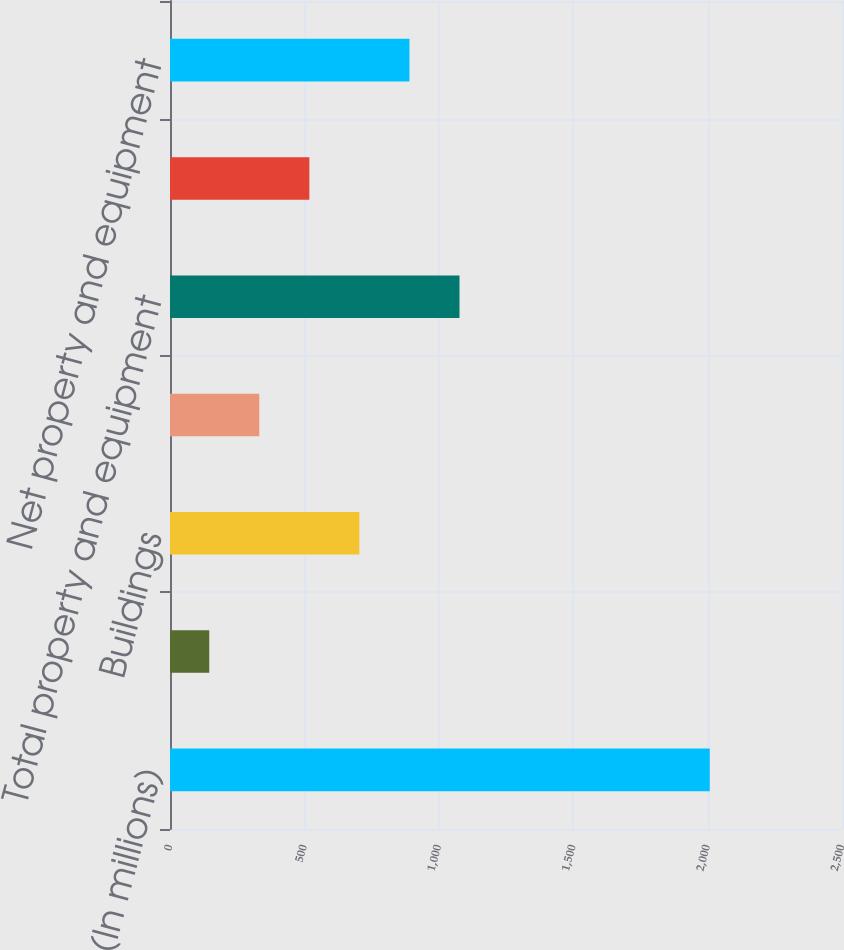<chart> <loc_0><loc_0><loc_500><loc_500><bar_chart><fcel>(In millions)<fcel>Land<fcel>Buildings<fcel>Equipment<fcel>Total property and equipment<fcel>Less accumulated depreciation<fcel>Net property and equipment<nl><fcel>2008<fcel>146<fcel>704.6<fcel>332.2<fcel>1077<fcel>518.4<fcel>890.8<nl></chart> 